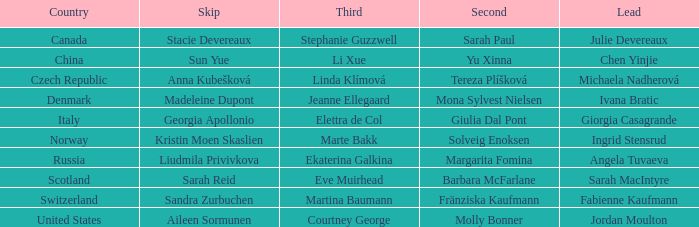What bypass has switzerland as the territory? Sandra Zurbuchen. 